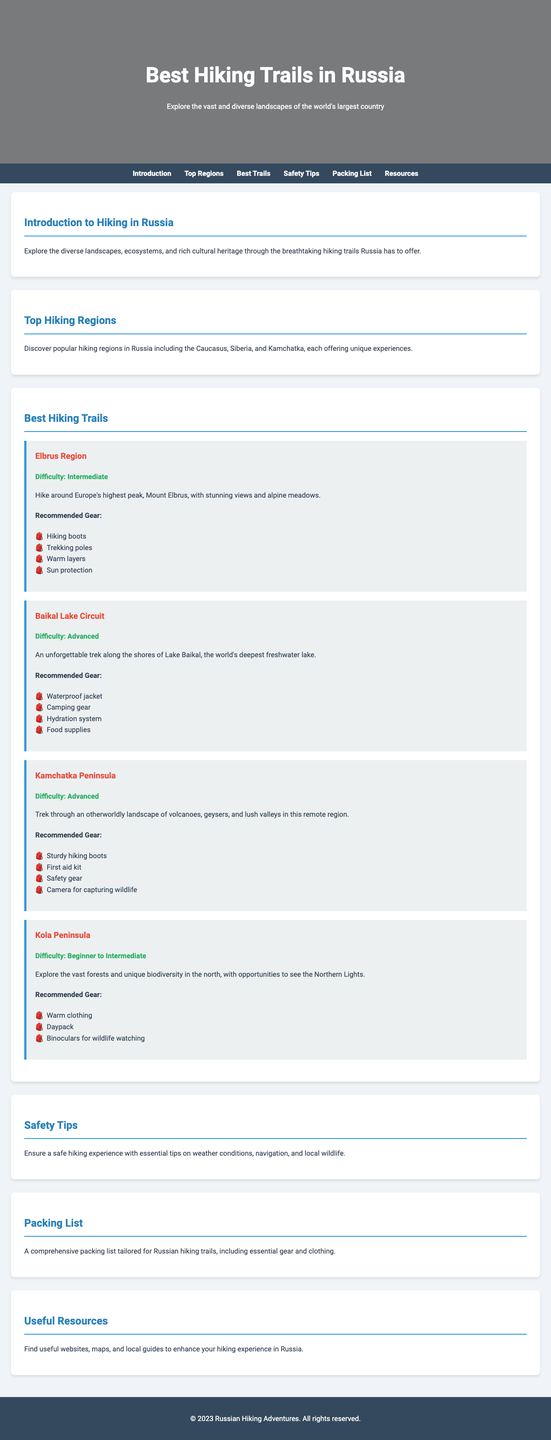What is the title of the guide? The title of the guide is stated in the header section of the document.
Answer: Best Hiking Trails in Russia What are the top hiking regions mentioned? The document lists popular hiking regions in Russia.
Answer: Caucasus, Siberia, Kamchatka What is the difficulty level of the Baikal Lake Circuit? The difficulty level is specified in the description of each hiking trail.
Answer: Advanced What type of gear is recommended for the Elbrus Region trail? The document provides a list of recommended gear for each trail.
Answer: Hiking boots, trekking poles, warm layers, sun protection Which hiking trail allows for opportunities to see the Northern Lights? The document mentions unique features for each hiking trail, including this one.
Answer: Kola Peninsula What is the main theme of the introduction? The introduction provides an overview of what to expect while hiking in Russia.
Answer: Diverse landscapes and cultural heritage How many hiking trails are listed in the document? The total number of trails can be counted from the trails section.
Answer: Four What is emphasized in the safety tips section? The safety section provides essential information for hikers to ensure a safe experience.
Answer: Weather conditions, navigation, local wildlife 